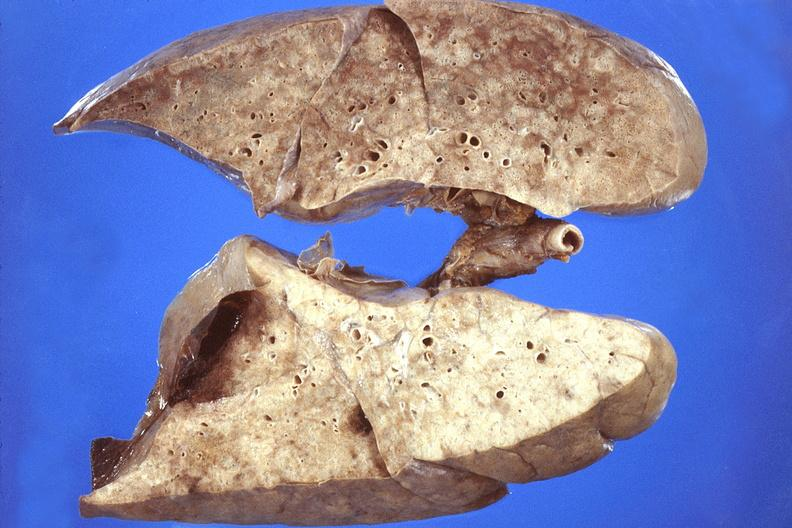does endometrial polyp show lung, pneumocystis pneumonia?
Answer the question using a single word or phrase. No 